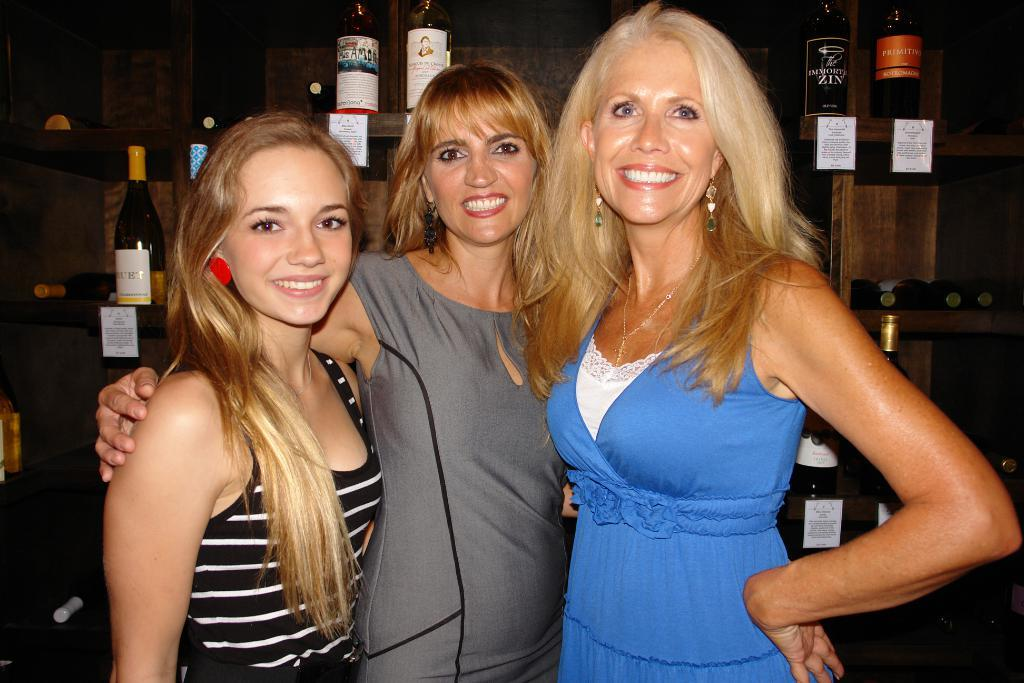How many girls are present in the image? There are three girls in the image. What are the girls doing in the image? The girls are standing beside each other. What can be seen in the background of the image? There are wine bottles in the background of the image. How are the wine bottles arranged in the image? The wine bottles are kept on wooden shelves. What type of jar is being discussed by the committee in the image? There is no committee or jar present in the image. What type of trade is being conducted by the girls in the image? There is no trade being conducted by the girls in the image; they are simply standing beside each other. 